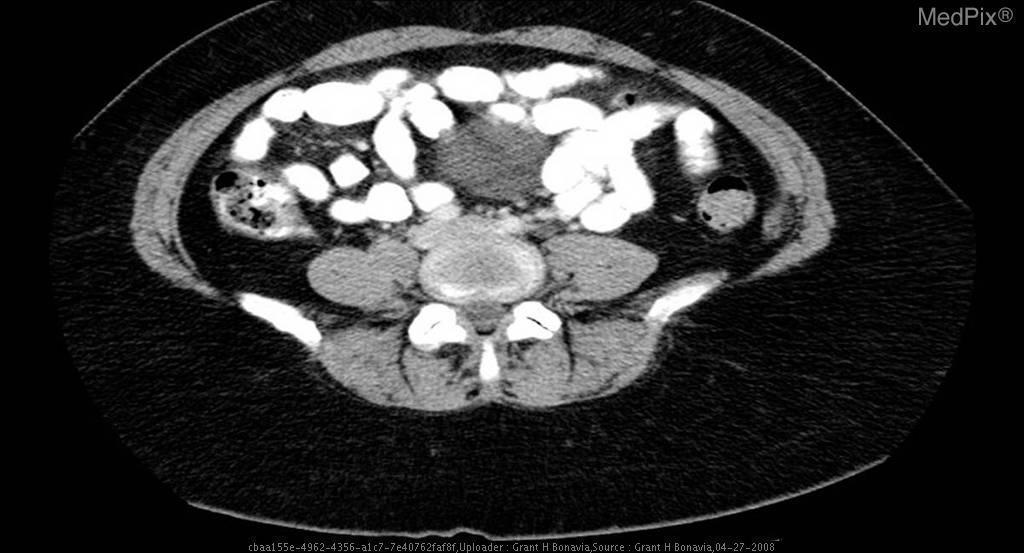Is the sigmoid colon visualized at this axial section?
Quick response, please. Yes. What form of contrast did the patient receive?
Answer briefly. Oral and iv. What types of contrast did this patient have?
Write a very short answer. Oral and iv. What is located in the sigmoid colon?
Give a very brief answer. Diverticuli. What are the findings in the sigmoid colon?
Answer briefly. Diverticuli. What are the internal morphologic features of this mass?
Quick response, please. Cystic. Is this a cystic or solid mass?
Give a very brief answer. Cystic. 